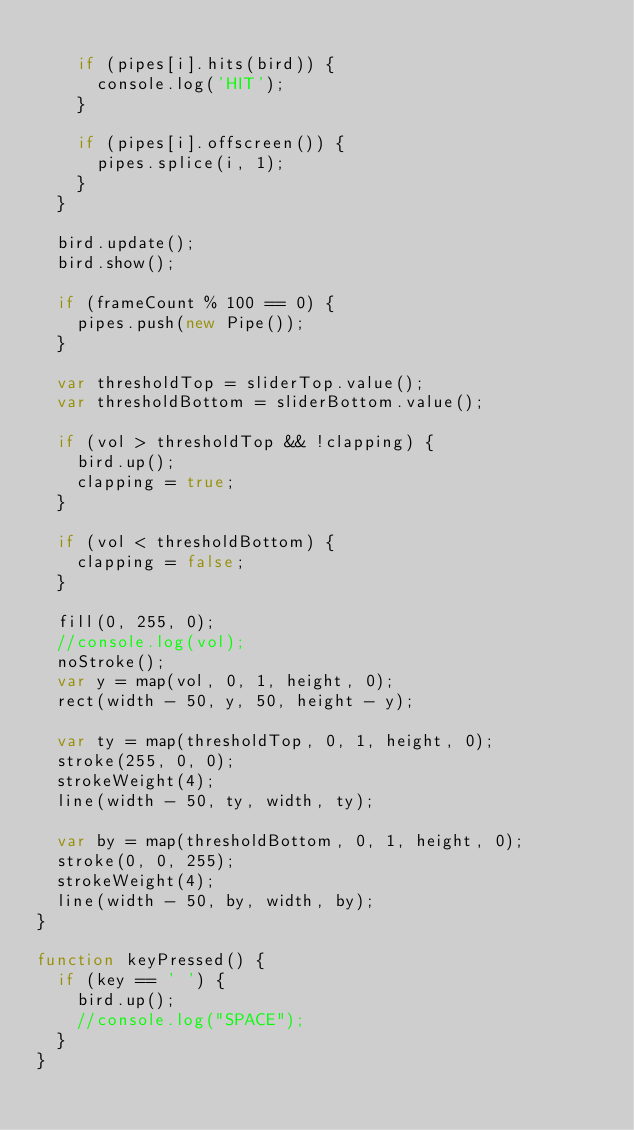Convert code to text. <code><loc_0><loc_0><loc_500><loc_500><_JavaScript_>
    if (pipes[i].hits(bird)) {
      console.log('HIT');
    }

    if (pipes[i].offscreen()) {
      pipes.splice(i, 1);
    }
  }

  bird.update();
  bird.show();

  if (frameCount % 100 == 0) {
    pipes.push(new Pipe());
  }

  var thresholdTop = sliderTop.value();
  var thresholdBottom = sliderBottom.value();

  if (vol > thresholdTop && !clapping) {
    bird.up();
    clapping = true;
  }

  if (vol < thresholdBottom) {
    clapping = false;
  }

  fill(0, 255, 0);
  //console.log(vol);
  noStroke();
  var y = map(vol, 0, 1, height, 0);
  rect(width - 50, y, 50, height - y);

  var ty = map(thresholdTop, 0, 1, height, 0);
  stroke(255, 0, 0);
  strokeWeight(4);
  line(width - 50, ty, width, ty);

  var by = map(thresholdBottom, 0, 1, height, 0);
  stroke(0, 0, 255);
  strokeWeight(4);
  line(width - 50, by, width, by);
}

function keyPressed() {
  if (key == ' ') {
    bird.up();
    //console.log("SPACE");
  }
}
</code> 